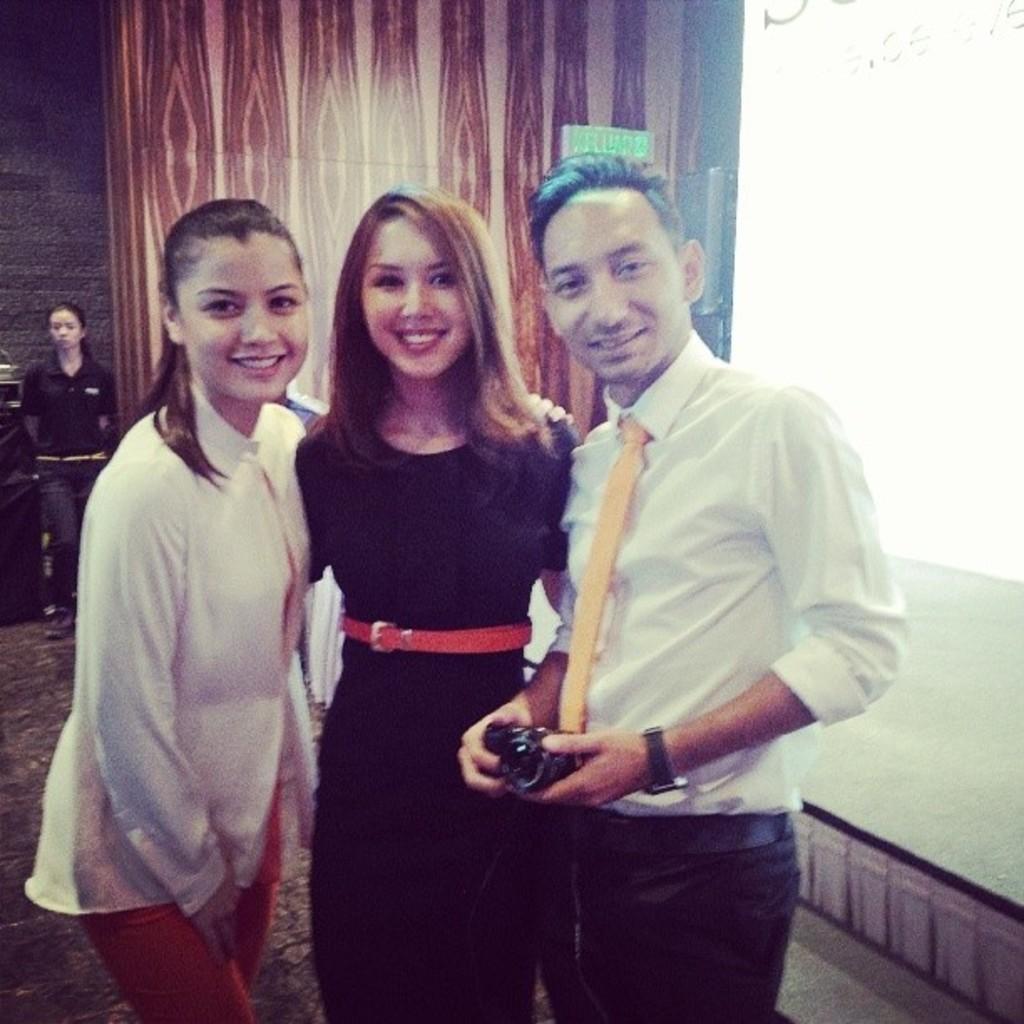Can you describe this image briefly? In this picture I can see few people are standing and I can see a man holding a camera in his hands and I can see another woman standing in the back and looks like a projector light on the right side of the picture and displaying text. 